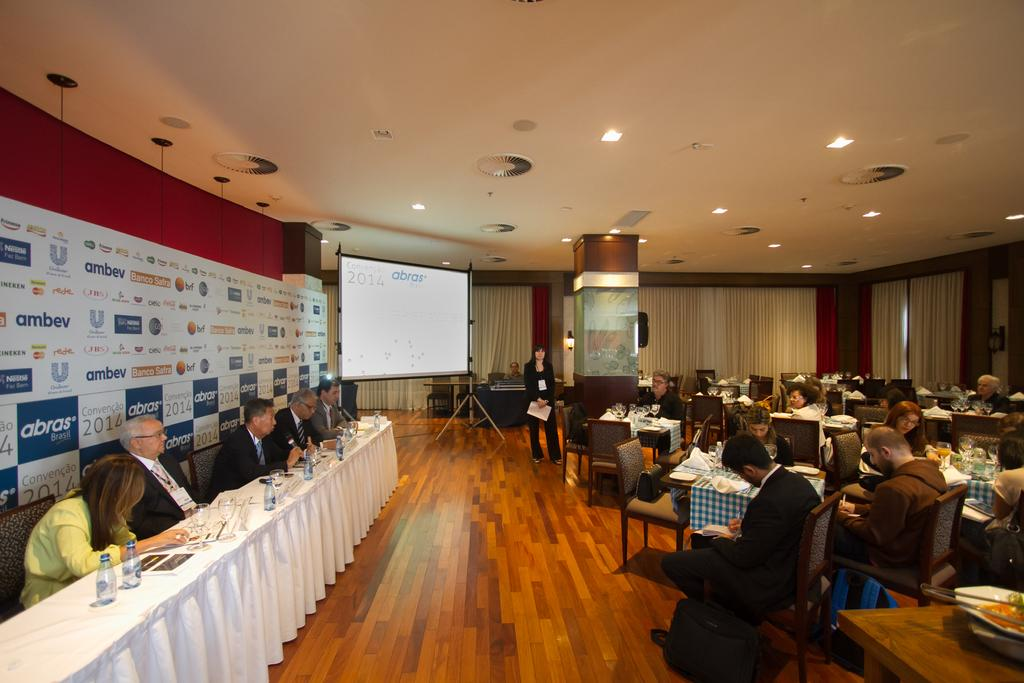What type of structure can be seen in the image? There is a wall in the image. What is located near the wall? There is a screen in the image. What are the people in the image doing? The people are sitting in the image. What is on the table in the image? There are bottles and glasses on the table. What is the opinion of the butter on the table in the image? There is no butter present in the image, so it is not possible to determine its opinion. 